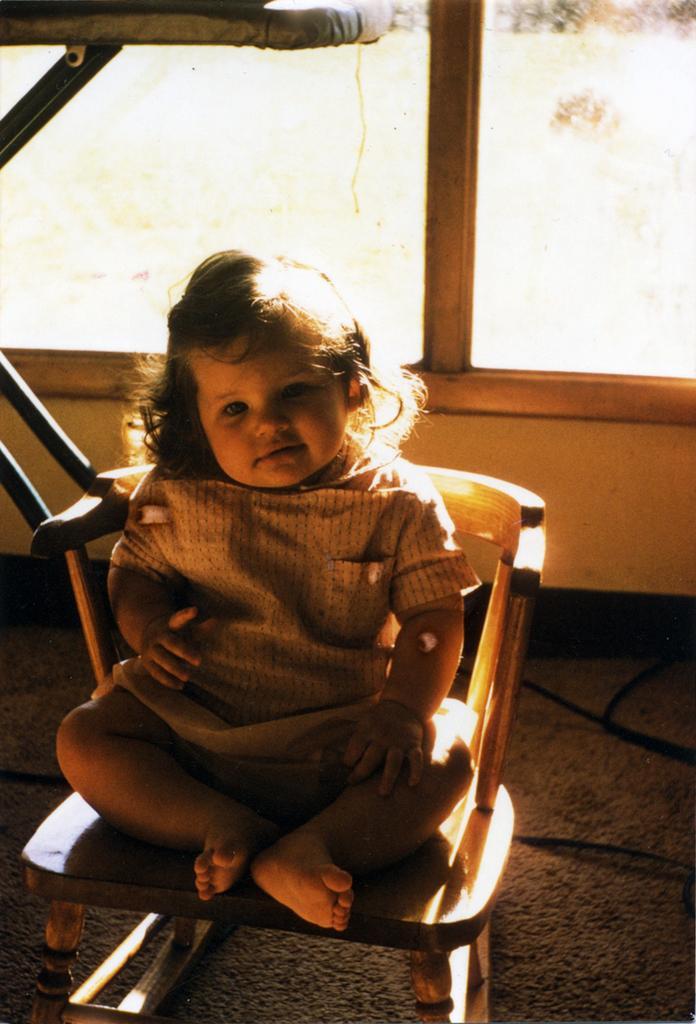Please provide a concise description of this image. In this picture we can see a kid sitting on the chair. And this is the floor. 